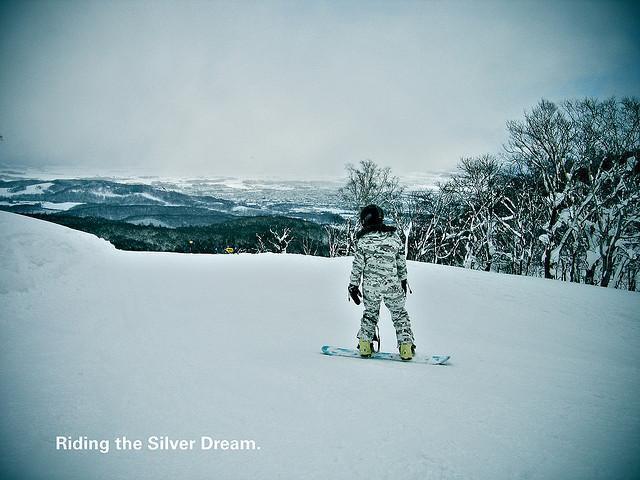How many donuts are on the plate?
Give a very brief answer. 0. 